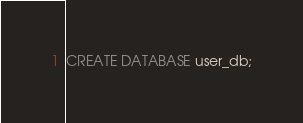<code> <loc_0><loc_0><loc_500><loc_500><_SQL_>
CREATE DATABASE user_db;
</code> 